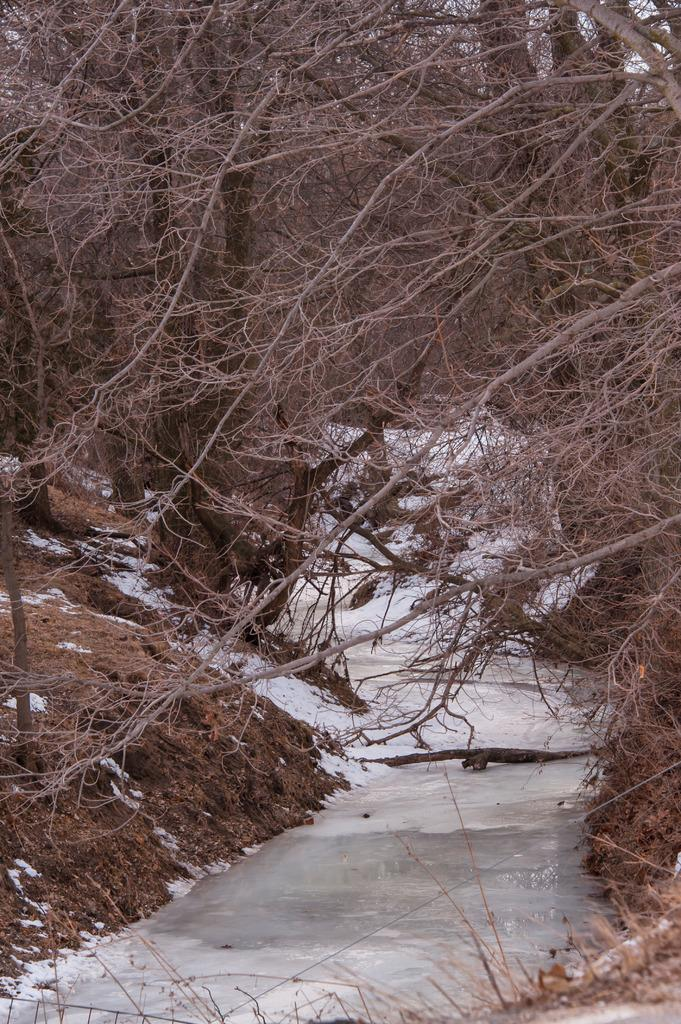What type of vegetation can be seen in the image? There are trees in the image. What is the other element visible in the image besides the trees? There is ice visible in the image. What type of pets can be seen playing with the ice in the image? There are no pets present in the image; it only features trees and ice. What type of beast can be seen interacting with the trees in the image? There is no beast present in the image; it only features trees and ice. 